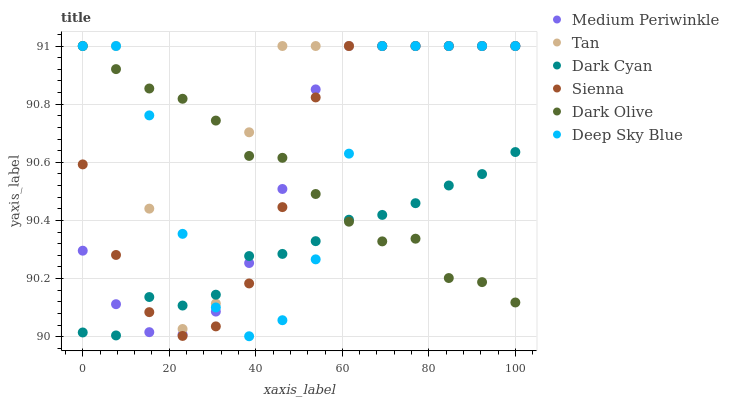Does Dark Cyan have the minimum area under the curve?
Answer yes or no. Yes. Does Tan have the maximum area under the curve?
Answer yes or no. Yes. Does Medium Periwinkle have the minimum area under the curve?
Answer yes or no. No. Does Medium Periwinkle have the maximum area under the curve?
Answer yes or no. No. Is Dark Cyan the smoothest?
Answer yes or no. Yes. Is Tan the roughest?
Answer yes or no. Yes. Is Medium Periwinkle the smoothest?
Answer yes or no. No. Is Medium Periwinkle the roughest?
Answer yes or no. No. Does Deep Sky Blue have the lowest value?
Answer yes or no. Yes. Does Medium Periwinkle have the lowest value?
Answer yes or no. No. Does Tan have the highest value?
Answer yes or no. Yes. Does Dark Cyan have the highest value?
Answer yes or no. No. Does Dark Cyan intersect Medium Periwinkle?
Answer yes or no. Yes. Is Dark Cyan less than Medium Periwinkle?
Answer yes or no. No. Is Dark Cyan greater than Medium Periwinkle?
Answer yes or no. No. 